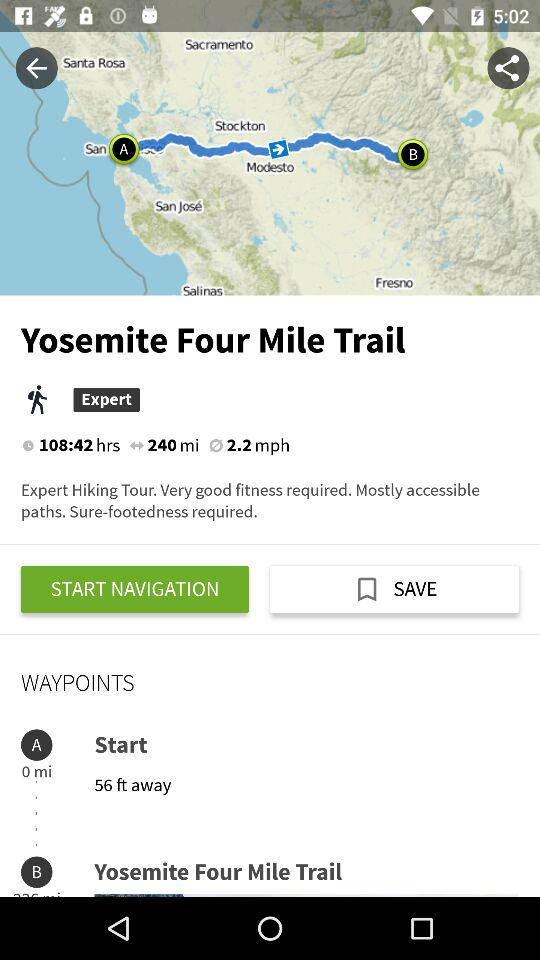What is the name of the trail? The name is "Yosemite Four Mile Trail". 